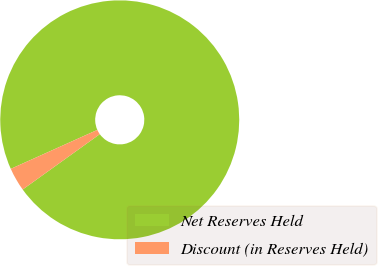Convert chart to OTSL. <chart><loc_0><loc_0><loc_500><loc_500><pie_chart><fcel>Net Reserves Held<fcel>Discount (in Reserves Held)<nl><fcel>96.82%<fcel>3.18%<nl></chart> 